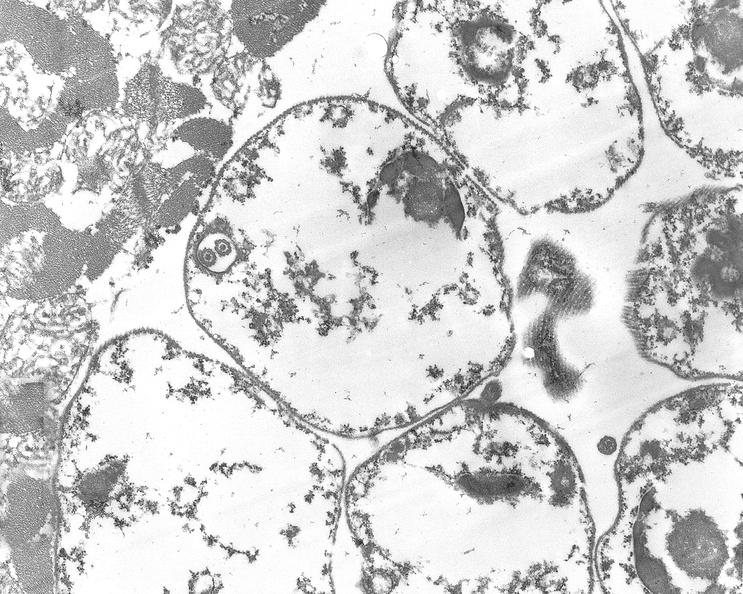s cardiovascular present?
Answer the question using a single word or phrase. Yes 